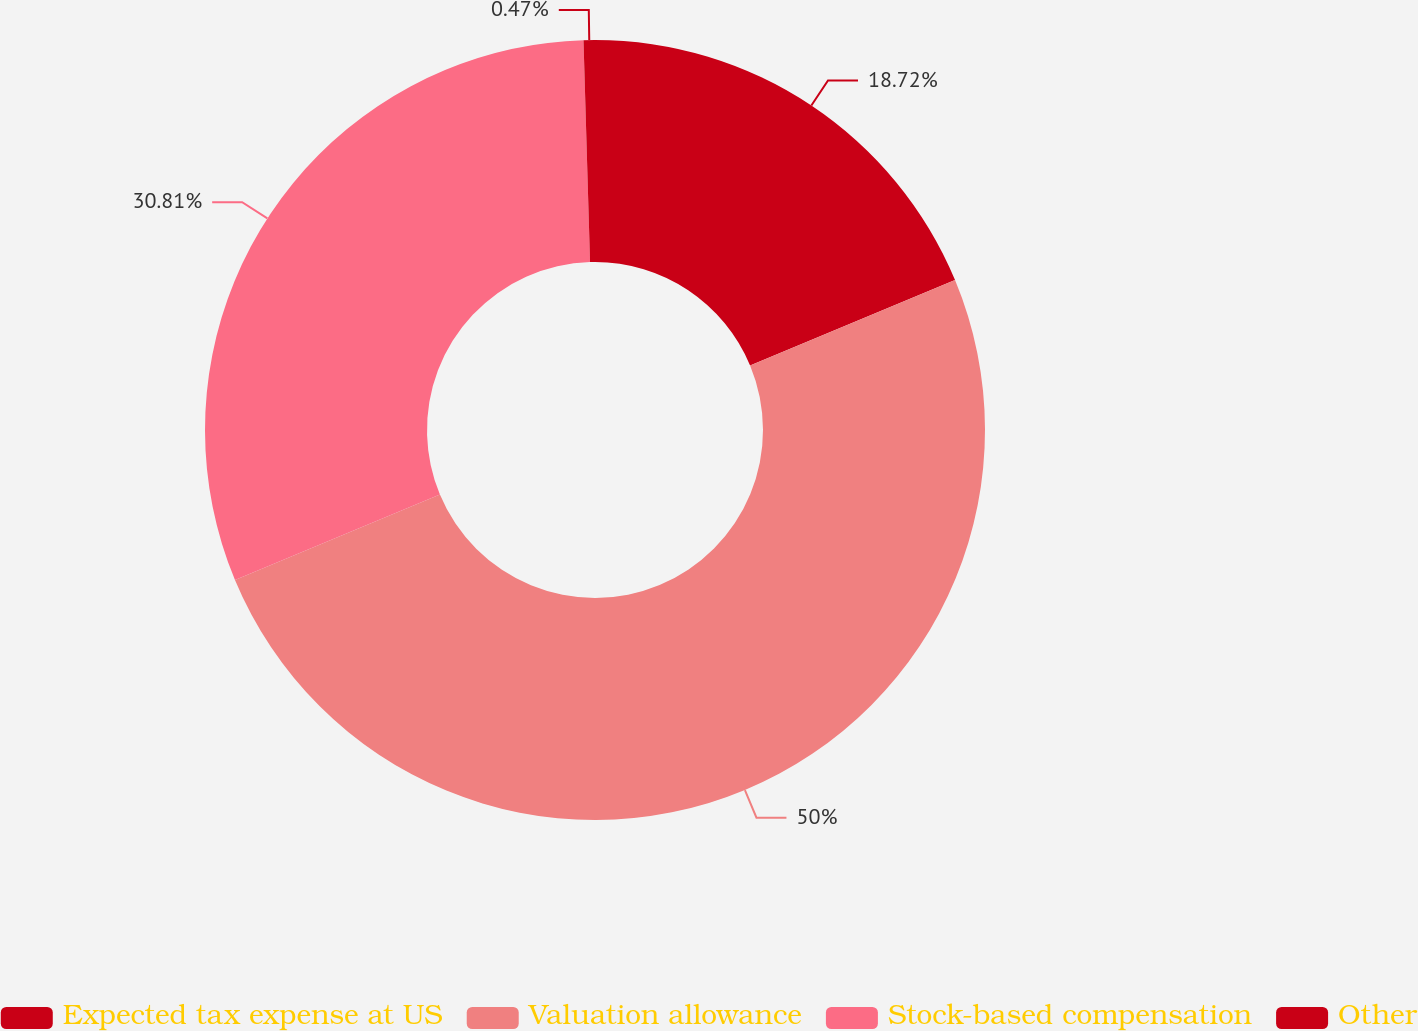<chart> <loc_0><loc_0><loc_500><loc_500><pie_chart><fcel>Expected tax expense at US<fcel>Valuation allowance<fcel>Stock-based compensation<fcel>Other<nl><fcel>18.72%<fcel>50.0%<fcel>30.81%<fcel>0.47%<nl></chart> 